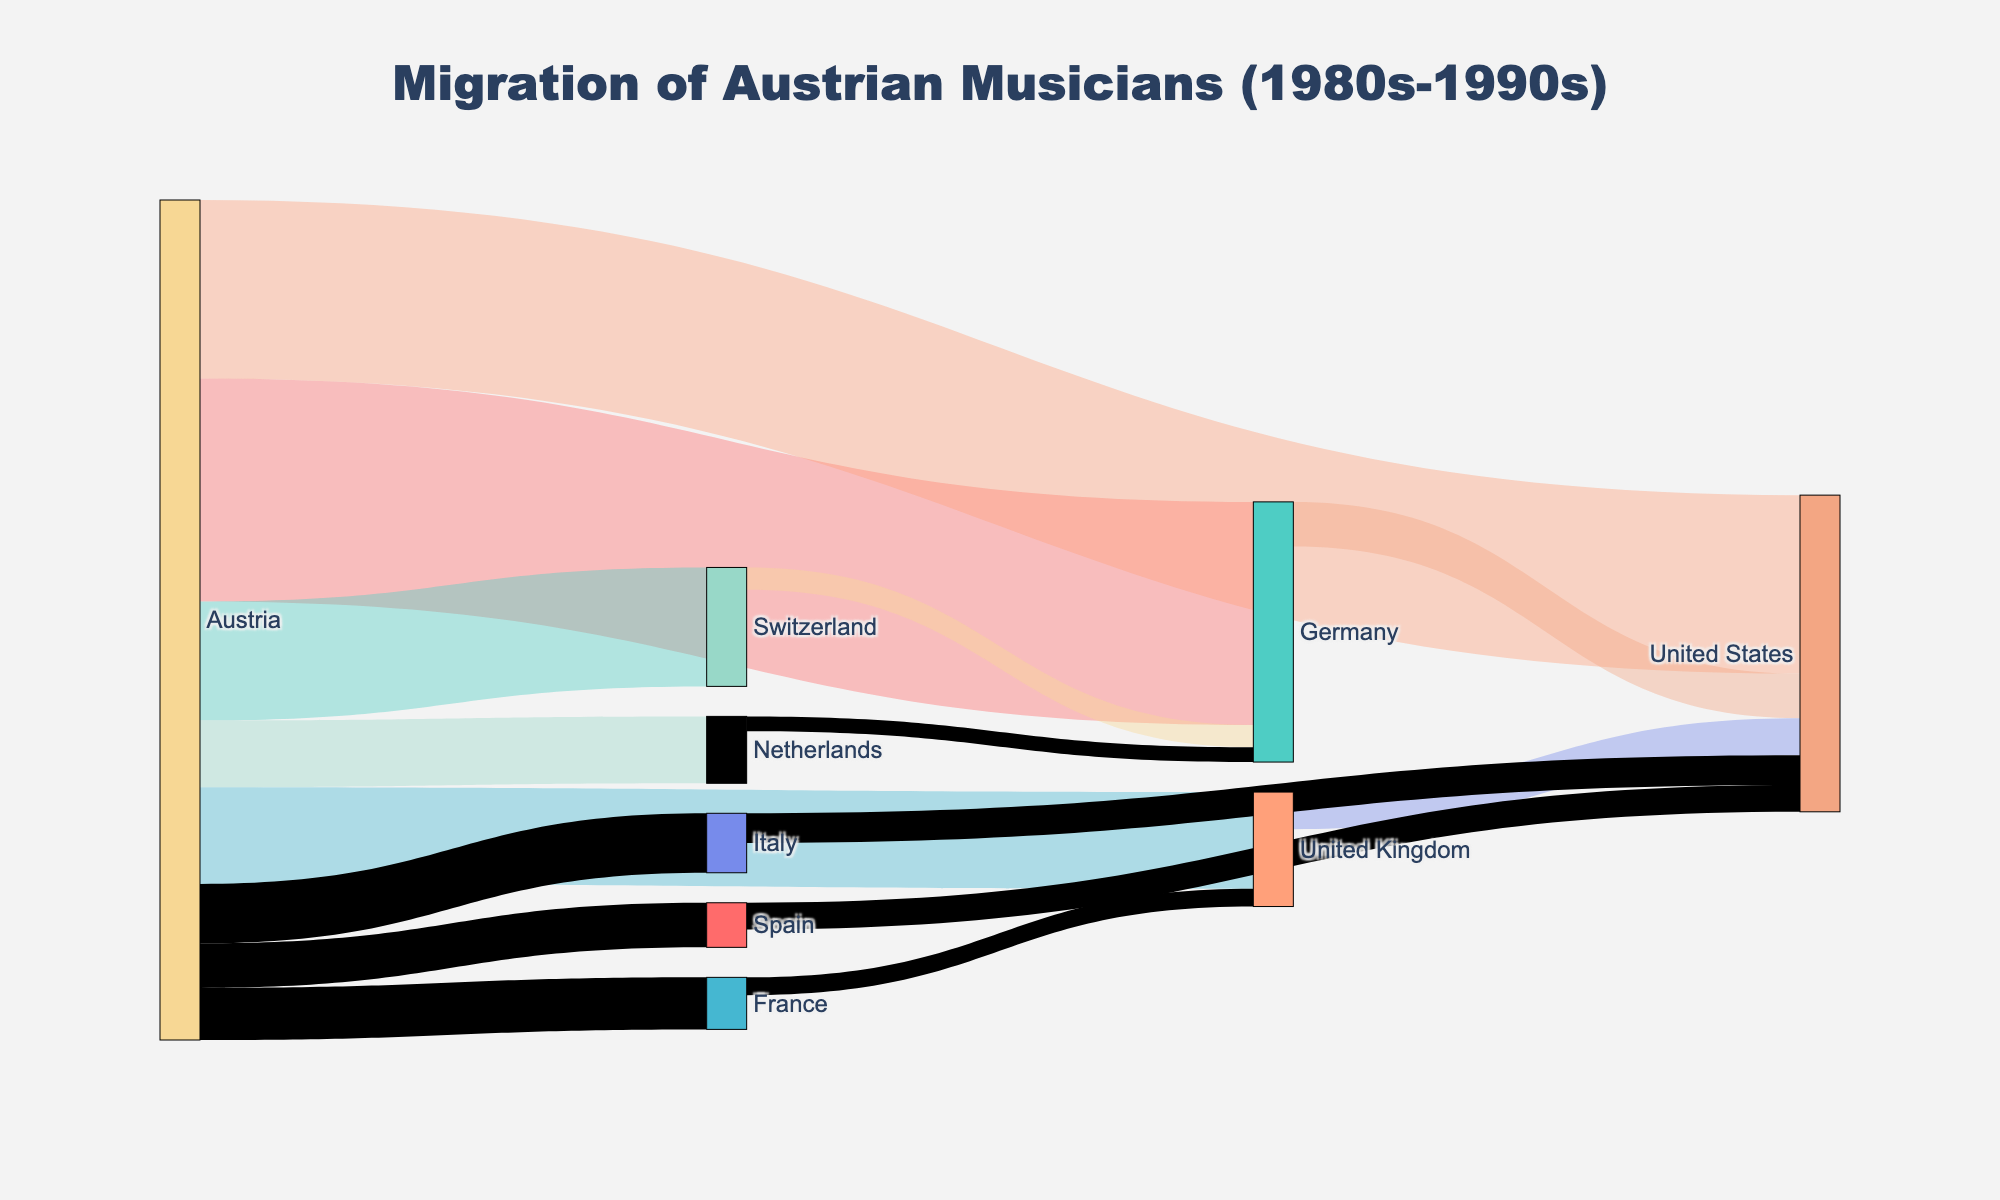What's the title of the figure? Look at the top of the figure where the title is usually placed. The title of this figure is "Migration of Austrian Musicians (1980s-1990s)"
Answer: Migration of Austrian Musicians (1980s-1990s) How many countries did Austrian musicians migrate to, as shown in the figure? Count the unique countries listed in the target nodes. These are Germany, Switzerland, United Kingdom, United States, Netherlands, Italy, France, and Spain, which makes 8 countries.
Answer: 8 Which country received the highest number of musicians from Austria? Observe the widths of the links originating from Austria. The link to Germany has the largest width, representing the highest value of 150 musicians.
Answer: Germany What is the sum of musicians who migrated from Austria to Germany, the United States, and Switzerland? Add the values for migrations from Austria to these three countries: 150 (Germany) + 120 (United States) + 80 (Switzerland) = 350.
Answer: 350 Did any country other than Austria send musicians to the United States? Check for any migrations to the United States from countries other than Austria in the figure. There are migrations from Germany (30), United Kingdom (25), Italy (20), and Spain (18).
Answer: Yes Which country had the smallest outflow of Austrian musicians? Compare the widths of the links originating from Austria. The smallest outflow is to the Netherlands, with a value of 45 musicians.
Answer: Netherlands What is the total number of Austrian musicians migrating to European countries only? Sum the values of migrations from Austria to Germany, Switzerland, United Kingdom, Netherlands, Italy, France, and Spain: 150 + 80 + 65 + 45 + 40 + 35 + 30 = 445.
Answer: 445 Compare the number of musicians migrating to Switzerland with those going to Italy. Which country received more and by how much? The figure shows Switzerland received 80 musicians, while Italy received 40. The difference is 80 - 40 = 40 more musicians for Switzerland.
Answer: Switzerland, by 40 How many musicians migrated from Switzerland to Germany? Observe the link from Switzerland to Germany. It shows a value of 15 musicians.
Answer: 15 Which European country has the music migration link to the United States with the highest value? Identify the European countries that have links to the United States and compare their values. Germany (30), United Kingdom (25), Italy (20), Spain (18). Germany has the highest value with 30.
Answer: Germany 